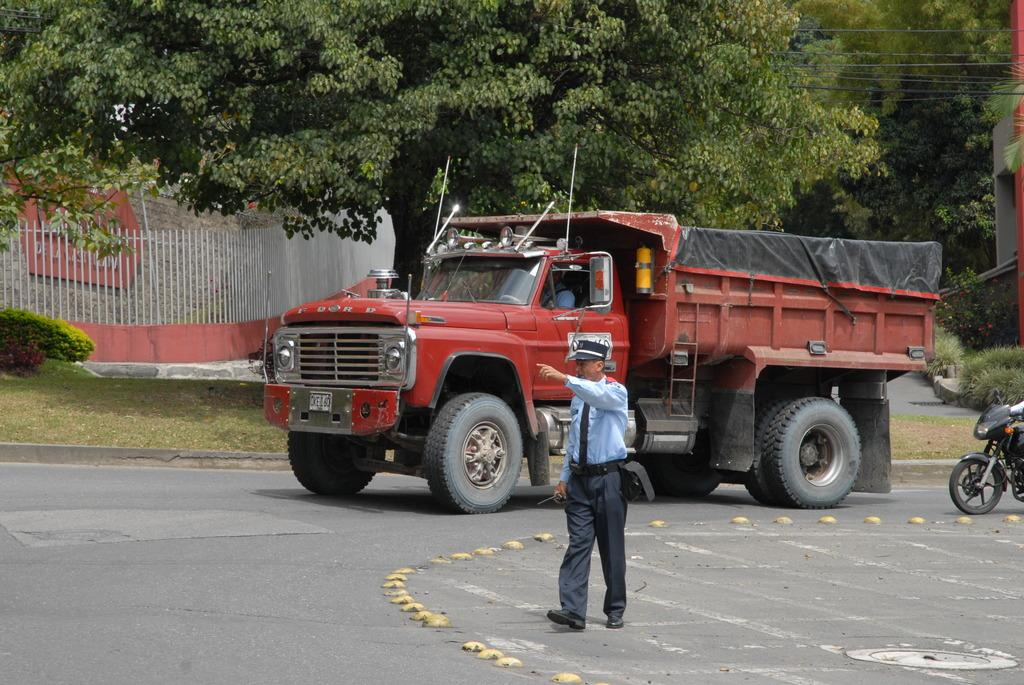What types of vehicles are in the image? There are vehicles in the image, but the specific types are not mentioned. What can be seen near the vehicles in the image? There is a railing in the image. What type of natural environment is visible in the image? There is grass, plants, and trees in the image. How many people are in the image? There are people in the image, with one person sitting inside a vehicle and another person walking on the road. What else can be seen in the image besides the vehicles and people? There are objects in the image. Can you tell me how many servants are present in the image? There is no mention of servants in the image; the people present are not described as servants. What type of pail can be seen being used by the person walking on the road? There is no pail present in the image; the person walking on the road is not holding or using any such object. 